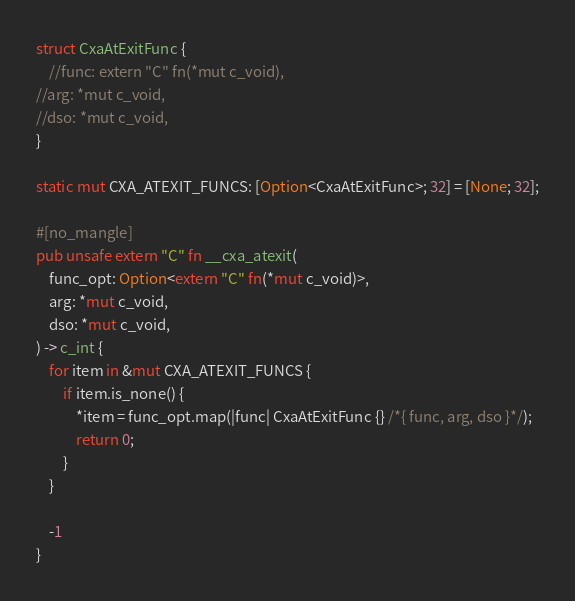Convert code to text. <code><loc_0><loc_0><loc_500><loc_500><_Rust_>struct CxaAtExitFunc {
    //func: extern "C" fn(*mut c_void),
//arg: *mut c_void,
//dso: *mut c_void,
}

static mut CXA_ATEXIT_FUNCS: [Option<CxaAtExitFunc>; 32] = [None; 32];

#[no_mangle]
pub unsafe extern "C" fn __cxa_atexit(
    func_opt: Option<extern "C" fn(*mut c_void)>,
    arg: *mut c_void,
    dso: *mut c_void,
) -> c_int {
    for item in &mut CXA_ATEXIT_FUNCS {
        if item.is_none() {
            *item = func_opt.map(|func| CxaAtExitFunc {} /*{ func, arg, dso }*/);
            return 0;
        }
    }

    -1
}
</code> 